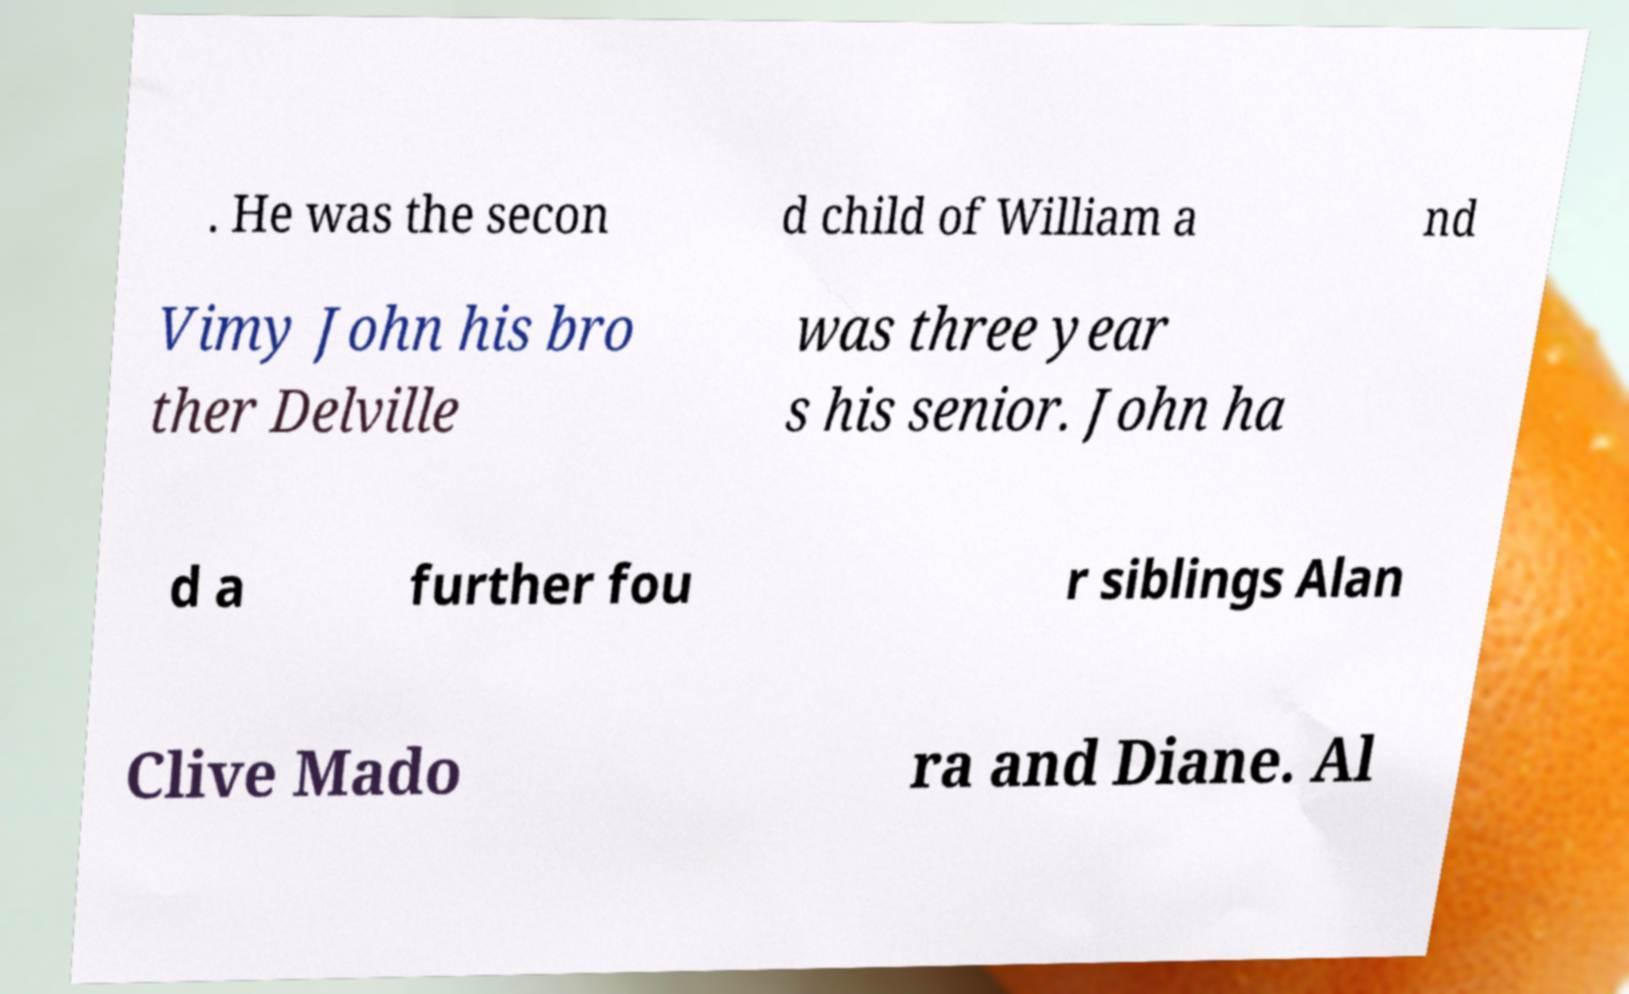Can you read and provide the text displayed in the image?This photo seems to have some interesting text. Can you extract and type it out for me? . He was the secon d child of William a nd Vimy John his bro ther Delville was three year s his senior. John ha d a further fou r siblings Alan Clive Mado ra and Diane. Al 